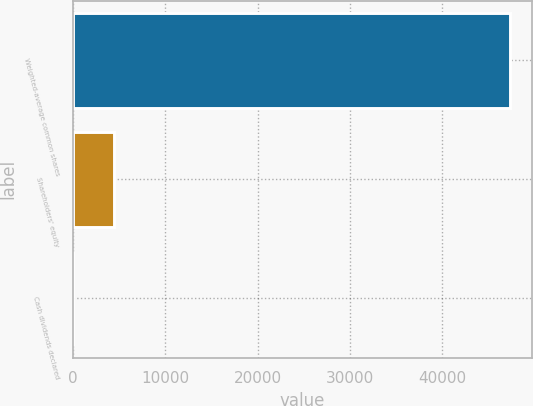<chart> <loc_0><loc_0><loc_500><loc_500><bar_chart><fcel>Weighted-average common shares<fcel>Shareholders' equity<fcel>Cash dividends declared<nl><fcel>47372.4<fcel>4388.53<fcel>0.15<nl></chart> 